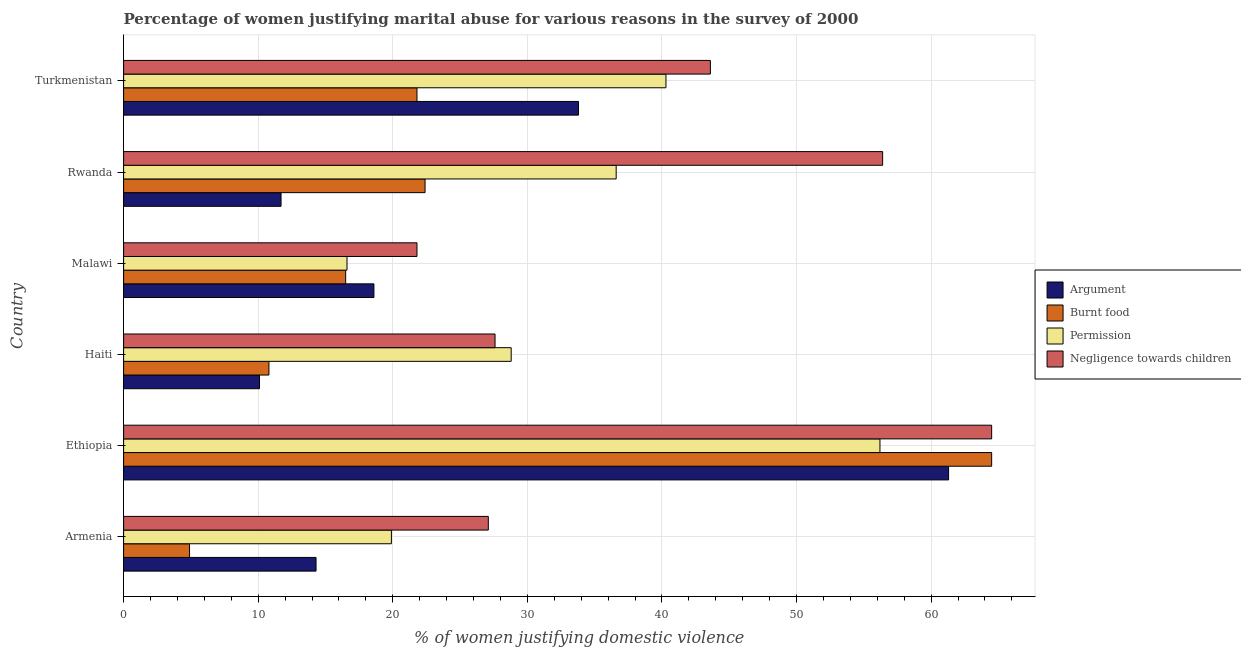How many groups of bars are there?
Ensure brevity in your answer.  6. Are the number of bars per tick equal to the number of legend labels?
Provide a short and direct response. Yes. Are the number of bars on each tick of the Y-axis equal?
Offer a very short reply. Yes. How many bars are there on the 1st tick from the top?
Your answer should be very brief. 4. What is the label of the 3rd group of bars from the top?
Your answer should be very brief. Malawi. What is the percentage of women justifying abuse for showing negligence towards children in Armenia?
Ensure brevity in your answer.  27.1. Across all countries, what is the maximum percentage of women justifying abuse in the case of an argument?
Your response must be concise. 61.3. Across all countries, what is the minimum percentage of women justifying abuse for burning food?
Offer a terse response. 4.9. In which country was the percentage of women justifying abuse for burning food maximum?
Offer a terse response. Ethiopia. In which country was the percentage of women justifying abuse for going without permission minimum?
Make the answer very short. Malawi. What is the total percentage of women justifying abuse for showing negligence towards children in the graph?
Offer a terse response. 241. What is the difference between the percentage of women justifying abuse for burning food in Armenia and the percentage of women justifying abuse for showing negligence towards children in Rwanda?
Provide a succinct answer. -51.5. What is the average percentage of women justifying abuse for burning food per country?
Ensure brevity in your answer.  23.48. What is the difference between the percentage of women justifying abuse for going without permission and percentage of women justifying abuse for showing negligence towards children in Haiti?
Offer a very short reply. 1.2. What is the ratio of the percentage of women justifying abuse for burning food in Armenia to that in Ethiopia?
Provide a short and direct response. 0.08. Is the percentage of women justifying abuse in the case of an argument in Armenia less than that in Malawi?
Offer a terse response. Yes. Is the difference between the percentage of women justifying abuse for showing negligence towards children in Malawi and Turkmenistan greater than the difference between the percentage of women justifying abuse for burning food in Malawi and Turkmenistan?
Give a very brief answer. No. What is the difference between the highest and the lowest percentage of women justifying abuse in the case of an argument?
Your response must be concise. 51.2. In how many countries, is the percentage of women justifying abuse in the case of an argument greater than the average percentage of women justifying abuse in the case of an argument taken over all countries?
Your response must be concise. 2. Is the sum of the percentage of women justifying abuse for burning food in Armenia and Ethiopia greater than the maximum percentage of women justifying abuse for showing negligence towards children across all countries?
Provide a short and direct response. Yes. What does the 2nd bar from the top in Haiti represents?
Your response must be concise. Permission. What does the 1st bar from the bottom in Malawi represents?
Ensure brevity in your answer.  Argument. Are the values on the major ticks of X-axis written in scientific E-notation?
Your response must be concise. No. Does the graph contain any zero values?
Provide a short and direct response. No. How many legend labels are there?
Ensure brevity in your answer.  4. What is the title of the graph?
Give a very brief answer. Percentage of women justifying marital abuse for various reasons in the survey of 2000. Does "Japan" appear as one of the legend labels in the graph?
Your response must be concise. No. What is the label or title of the X-axis?
Ensure brevity in your answer.  % of women justifying domestic violence. What is the label or title of the Y-axis?
Your answer should be compact. Country. What is the % of women justifying domestic violence in Burnt food in Armenia?
Keep it short and to the point. 4.9. What is the % of women justifying domestic violence in Negligence towards children in Armenia?
Offer a very short reply. 27.1. What is the % of women justifying domestic violence of Argument in Ethiopia?
Ensure brevity in your answer.  61.3. What is the % of women justifying domestic violence in Burnt food in Ethiopia?
Ensure brevity in your answer.  64.5. What is the % of women justifying domestic violence of Permission in Ethiopia?
Offer a terse response. 56.2. What is the % of women justifying domestic violence in Negligence towards children in Ethiopia?
Your answer should be very brief. 64.5. What is the % of women justifying domestic violence in Permission in Haiti?
Provide a succinct answer. 28.8. What is the % of women justifying domestic violence in Negligence towards children in Haiti?
Provide a succinct answer. 27.6. What is the % of women justifying domestic violence in Argument in Malawi?
Provide a short and direct response. 18.6. What is the % of women justifying domestic violence of Negligence towards children in Malawi?
Provide a succinct answer. 21.8. What is the % of women justifying domestic violence of Burnt food in Rwanda?
Make the answer very short. 22.4. What is the % of women justifying domestic violence in Permission in Rwanda?
Offer a very short reply. 36.6. What is the % of women justifying domestic violence in Negligence towards children in Rwanda?
Provide a short and direct response. 56.4. What is the % of women justifying domestic violence of Argument in Turkmenistan?
Ensure brevity in your answer.  33.8. What is the % of women justifying domestic violence of Burnt food in Turkmenistan?
Offer a terse response. 21.8. What is the % of women justifying domestic violence of Permission in Turkmenistan?
Make the answer very short. 40.3. What is the % of women justifying domestic violence in Negligence towards children in Turkmenistan?
Provide a succinct answer. 43.6. Across all countries, what is the maximum % of women justifying domestic violence of Argument?
Ensure brevity in your answer.  61.3. Across all countries, what is the maximum % of women justifying domestic violence of Burnt food?
Your answer should be compact. 64.5. Across all countries, what is the maximum % of women justifying domestic violence in Permission?
Offer a very short reply. 56.2. Across all countries, what is the maximum % of women justifying domestic violence in Negligence towards children?
Offer a terse response. 64.5. Across all countries, what is the minimum % of women justifying domestic violence of Argument?
Keep it short and to the point. 10.1. Across all countries, what is the minimum % of women justifying domestic violence of Burnt food?
Make the answer very short. 4.9. Across all countries, what is the minimum % of women justifying domestic violence in Permission?
Your answer should be very brief. 16.6. Across all countries, what is the minimum % of women justifying domestic violence of Negligence towards children?
Make the answer very short. 21.8. What is the total % of women justifying domestic violence of Argument in the graph?
Keep it short and to the point. 149.8. What is the total % of women justifying domestic violence of Burnt food in the graph?
Offer a terse response. 140.9. What is the total % of women justifying domestic violence of Permission in the graph?
Your answer should be very brief. 198.4. What is the total % of women justifying domestic violence of Negligence towards children in the graph?
Offer a terse response. 241. What is the difference between the % of women justifying domestic violence in Argument in Armenia and that in Ethiopia?
Your answer should be compact. -47. What is the difference between the % of women justifying domestic violence in Burnt food in Armenia and that in Ethiopia?
Your response must be concise. -59.6. What is the difference between the % of women justifying domestic violence in Permission in Armenia and that in Ethiopia?
Give a very brief answer. -36.3. What is the difference between the % of women justifying domestic violence of Negligence towards children in Armenia and that in Ethiopia?
Your response must be concise. -37.4. What is the difference between the % of women justifying domestic violence in Argument in Armenia and that in Haiti?
Keep it short and to the point. 4.2. What is the difference between the % of women justifying domestic violence of Negligence towards children in Armenia and that in Haiti?
Keep it short and to the point. -0.5. What is the difference between the % of women justifying domestic violence in Burnt food in Armenia and that in Malawi?
Your answer should be very brief. -11.6. What is the difference between the % of women justifying domestic violence in Permission in Armenia and that in Malawi?
Offer a very short reply. 3.3. What is the difference between the % of women justifying domestic violence of Negligence towards children in Armenia and that in Malawi?
Provide a succinct answer. 5.3. What is the difference between the % of women justifying domestic violence in Burnt food in Armenia and that in Rwanda?
Offer a very short reply. -17.5. What is the difference between the % of women justifying domestic violence in Permission in Armenia and that in Rwanda?
Give a very brief answer. -16.7. What is the difference between the % of women justifying domestic violence of Negligence towards children in Armenia and that in Rwanda?
Provide a succinct answer. -29.3. What is the difference between the % of women justifying domestic violence in Argument in Armenia and that in Turkmenistan?
Offer a very short reply. -19.5. What is the difference between the % of women justifying domestic violence in Burnt food in Armenia and that in Turkmenistan?
Provide a succinct answer. -16.9. What is the difference between the % of women justifying domestic violence in Permission in Armenia and that in Turkmenistan?
Keep it short and to the point. -20.4. What is the difference between the % of women justifying domestic violence in Negligence towards children in Armenia and that in Turkmenistan?
Offer a very short reply. -16.5. What is the difference between the % of women justifying domestic violence of Argument in Ethiopia and that in Haiti?
Provide a short and direct response. 51.2. What is the difference between the % of women justifying domestic violence in Burnt food in Ethiopia and that in Haiti?
Provide a succinct answer. 53.7. What is the difference between the % of women justifying domestic violence of Permission in Ethiopia and that in Haiti?
Your answer should be compact. 27.4. What is the difference between the % of women justifying domestic violence in Negligence towards children in Ethiopia and that in Haiti?
Provide a succinct answer. 36.9. What is the difference between the % of women justifying domestic violence in Argument in Ethiopia and that in Malawi?
Your answer should be compact. 42.7. What is the difference between the % of women justifying domestic violence of Permission in Ethiopia and that in Malawi?
Provide a short and direct response. 39.6. What is the difference between the % of women justifying domestic violence of Negligence towards children in Ethiopia and that in Malawi?
Ensure brevity in your answer.  42.7. What is the difference between the % of women justifying domestic violence in Argument in Ethiopia and that in Rwanda?
Keep it short and to the point. 49.6. What is the difference between the % of women justifying domestic violence of Burnt food in Ethiopia and that in Rwanda?
Provide a succinct answer. 42.1. What is the difference between the % of women justifying domestic violence in Permission in Ethiopia and that in Rwanda?
Ensure brevity in your answer.  19.6. What is the difference between the % of women justifying domestic violence in Negligence towards children in Ethiopia and that in Rwanda?
Offer a very short reply. 8.1. What is the difference between the % of women justifying domestic violence in Argument in Ethiopia and that in Turkmenistan?
Provide a succinct answer. 27.5. What is the difference between the % of women justifying domestic violence in Burnt food in Ethiopia and that in Turkmenistan?
Offer a terse response. 42.7. What is the difference between the % of women justifying domestic violence in Negligence towards children in Ethiopia and that in Turkmenistan?
Keep it short and to the point. 20.9. What is the difference between the % of women justifying domestic violence in Burnt food in Haiti and that in Rwanda?
Offer a terse response. -11.6. What is the difference between the % of women justifying domestic violence of Negligence towards children in Haiti and that in Rwanda?
Provide a succinct answer. -28.8. What is the difference between the % of women justifying domestic violence of Argument in Haiti and that in Turkmenistan?
Your answer should be compact. -23.7. What is the difference between the % of women justifying domestic violence of Burnt food in Haiti and that in Turkmenistan?
Give a very brief answer. -11. What is the difference between the % of women justifying domestic violence of Negligence towards children in Haiti and that in Turkmenistan?
Make the answer very short. -16. What is the difference between the % of women justifying domestic violence of Argument in Malawi and that in Rwanda?
Your answer should be very brief. 6.9. What is the difference between the % of women justifying domestic violence in Permission in Malawi and that in Rwanda?
Give a very brief answer. -20. What is the difference between the % of women justifying domestic violence of Negligence towards children in Malawi and that in Rwanda?
Offer a terse response. -34.6. What is the difference between the % of women justifying domestic violence in Argument in Malawi and that in Turkmenistan?
Offer a very short reply. -15.2. What is the difference between the % of women justifying domestic violence in Permission in Malawi and that in Turkmenistan?
Your response must be concise. -23.7. What is the difference between the % of women justifying domestic violence of Negligence towards children in Malawi and that in Turkmenistan?
Make the answer very short. -21.8. What is the difference between the % of women justifying domestic violence of Argument in Rwanda and that in Turkmenistan?
Give a very brief answer. -22.1. What is the difference between the % of women justifying domestic violence in Permission in Rwanda and that in Turkmenistan?
Provide a short and direct response. -3.7. What is the difference between the % of women justifying domestic violence of Argument in Armenia and the % of women justifying domestic violence of Burnt food in Ethiopia?
Your response must be concise. -50.2. What is the difference between the % of women justifying domestic violence of Argument in Armenia and the % of women justifying domestic violence of Permission in Ethiopia?
Keep it short and to the point. -41.9. What is the difference between the % of women justifying domestic violence in Argument in Armenia and the % of women justifying domestic violence in Negligence towards children in Ethiopia?
Offer a very short reply. -50.2. What is the difference between the % of women justifying domestic violence in Burnt food in Armenia and the % of women justifying domestic violence in Permission in Ethiopia?
Provide a short and direct response. -51.3. What is the difference between the % of women justifying domestic violence of Burnt food in Armenia and the % of women justifying domestic violence of Negligence towards children in Ethiopia?
Offer a very short reply. -59.6. What is the difference between the % of women justifying domestic violence of Permission in Armenia and the % of women justifying domestic violence of Negligence towards children in Ethiopia?
Make the answer very short. -44.6. What is the difference between the % of women justifying domestic violence in Argument in Armenia and the % of women justifying domestic violence in Permission in Haiti?
Provide a succinct answer. -14.5. What is the difference between the % of women justifying domestic violence in Argument in Armenia and the % of women justifying domestic violence in Negligence towards children in Haiti?
Give a very brief answer. -13.3. What is the difference between the % of women justifying domestic violence in Burnt food in Armenia and the % of women justifying domestic violence in Permission in Haiti?
Give a very brief answer. -23.9. What is the difference between the % of women justifying domestic violence in Burnt food in Armenia and the % of women justifying domestic violence in Negligence towards children in Haiti?
Your answer should be very brief. -22.7. What is the difference between the % of women justifying domestic violence in Burnt food in Armenia and the % of women justifying domestic violence in Negligence towards children in Malawi?
Keep it short and to the point. -16.9. What is the difference between the % of women justifying domestic violence in Argument in Armenia and the % of women justifying domestic violence in Permission in Rwanda?
Your response must be concise. -22.3. What is the difference between the % of women justifying domestic violence in Argument in Armenia and the % of women justifying domestic violence in Negligence towards children in Rwanda?
Provide a succinct answer. -42.1. What is the difference between the % of women justifying domestic violence in Burnt food in Armenia and the % of women justifying domestic violence in Permission in Rwanda?
Keep it short and to the point. -31.7. What is the difference between the % of women justifying domestic violence in Burnt food in Armenia and the % of women justifying domestic violence in Negligence towards children in Rwanda?
Keep it short and to the point. -51.5. What is the difference between the % of women justifying domestic violence of Permission in Armenia and the % of women justifying domestic violence of Negligence towards children in Rwanda?
Your response must be concise. -36.5. What is the difference between the % of women justifying domestic violence in Argument in Armenia and the % of women justifying domestic violence in Permission in Turkmenistan?
Offer a very short reply. -26. What is the difference between the % of women justifying domestic violence of Argument in Armenia and the % of women justifying domestic violence of Negligence towards children in Turkmenistan?
Offer a terse response. -29.3. What is the difference between the % of women justifying domestic violence of Burnt food in Armenia and the % of women justifying domestic violence of Permission in Turkmenistan?
Your response must be concise. -35.4. What is the difference between the % of women justifying domestic violence in Burnt food in Armenia and the % of women justifying domestic violence in Negligence towards children in Turkmenistan?
Make the answer very short. -38.7. What is the difference between the % of women justifying domestic violence in Permission in Armenia and the % of women justifying domestic violence in Negligence towards children in Turkmenistan?
Make the answer very short. -23.7. What is the difference between the % of women justifying domestic violence in Argument in Ethiopia and the % of women justifying domestic violence in Burnt food in Haiti?
Give a very brief answer. 50.5. What is the difference between the % of women justifying domestic violence of Argument in Ethiopia and the % of women justifying domestic violence of Permission in Haiti?
Provide a succinct answer. 32.5. What is the difference between the % of women justifying domestic violence in Argument in Ethiopia and the % of women justifying domestic violence in Negligence towards children in Haiti?
Make the answer very short. 33.7. What is the difference between the % of women justifying domestic violence of Burnt food in Ethiopia and the % of women justifying domestic violence of Permission in Haiti?
Ensure brevity in your answer.  35.7. What is the difference between the % of women justifying domestic violence in Burnt food in Ethiopia and the % of women justifying domestic violence in Negligence towards children in Haiti?
Give a very brief answer. 36.9. What is the difference between the % of women justifying domestic violence in Permission in Ethiopia and the % of women justifying domestic violence in Negligence towards children in Haiti?
Make the answer very short. 28.6. What is the difference between the % of women justifying domestic violence of Argument in Ethiopia and the % of women justifying domestic violence of Burnt food in Malawi?
Your answer should be compact. 44.8. What is the difference between the % of women justifying domestic violence of Argument in Ethiopia and the % of women justifying domestic violence of Permission in Malawi?
Your answer should be compact. 44.7. What is the difference between the % of women justifying domestic violence in Argument in Ethiopia and the % of women justifying domestic violence in Negligence towards children in Malawi?
Your answer should be very brief. 39.5. What is the difference between the % of women justifying domestic violence in Burnt food in Ethiopia and the % of women justifying domestic violence in Permission in Malawi?
Give a very brief answer. 47.9. What is the difference between the % of women justifying domestic violence in Burnt food in Ethiopia and the % of women justifying domestic violence in Negligence towards children in Malawi?
Give a very brief answer. 42.7. What is the difference between the % of women justifying domestic violence in Permission in Ethiopia and the % of women justifying domestic violence in Negligence towards children in Malawi?
Keep it short and to the point. 34.4. What is the difference between the % of women justifying domestic violence of Argument in Ethiopia and the % of women justifying domestic violence of Burnt food in Rwanda?
Provide a succinct answer. 38.9. What is the difference between the % of women justifying domestic violence of Argument in Ethiopia and the % of women justifying domestic violence of Permission in Rwanda?
Your answer should be compact. 24.7. What is the difference between the % of women justifying domestic violence in Argument in Ethiopia and the % of women justifying domestic violence in Negligence towards children in Rwanda?
Offer a very short reply. 4.9. What is the difference between the % of women justifying domestic violence of Burnt food in Ethiopia and the % of women justifying domestic violence of Permission in Rwanda?
Provide a succinct answer. 27.9. What is the difference between the % of women justifying domestic violence in Burnt food in Ethiopia and the % of women justifying domestic violence in Negligence towards children in Rwanda?
Provide a short and direct response. 8.1. What is the difference between the % of women justifying domestic violence of Argument in Ethiopia and the % of women justifying domestic violence of Burnt food in Turkmenistan?
Your answer should be very brief. 39.5. What is the difference between the % of women justifying domestic violence of Burnt food in Ethiopia and the % of women justifying domestic violence of Permission in Turkmenistan?
Keep it short and to the point. 24.2. What is the difference between the % of women justifying domestic violence of Burnt food in Ethiopia and the % of women justifying domestic violence of Negligence towards children in Turkmenistan?
Ensure brevity in your answer.  20.9. What is the difference between the % of women justifying domestic violence of Argument in Haiti and the % of women justifying domestic violence of Permission in Malawi?
Provide a succinct answer. -6.5. What is the difference between the % of women justifying domestic violence in Argument in Haiti and the % of women justifying domestic violence in Permission in Rwanda?
Keep it short and to the point. -26.5. What is the difference between the % of women justifying domestic violence in Argument in Haiti and the % of women justifying domestic violence in Negligence towards children in Rwanda?
Provide a succinct answer. -46.3. What is the difference between the % of women justifying domestic violence in Burnt food in Haiti and the % of women justifying domestic violence in Permission in Rwanda?
Your answer should be compact. -25.8. What is the difference between the % of women justifying domestic violence in Burnt food in Haiti and the % of women justifying domestic violence in Negligence towards children in Rwanda?
Provide a short and direct response. -45.6. What is the difference between the % of women justifying domestic violence of Permission in Haiti and the % of women justifying domestic violence of Negligence towards children in Rwanda?
Your answer should be very brief. -27.6. What is the difference between the % of women justifying domestic violence of Argument in Haiti and the % of women justifying domestic violence of Burnt food in Turkmenistan?
Your answer should be very brief. -11.7. What is the difference between the % of women justifying domestic violence of Argument in Haiti and the % of women justifying domestic violence of Permission in Turkmenistan?
Provide a short and direct response. -30.2. What is the difference between the % of women justifying domestic violence of Argument in Haiti and the % of women justifying domestic violence of Negligence towards children in Turkmenistan?
Offer a very short reply. -33.5. What is the difference between the % of women justifying domestic violence in Burnt food in Haiti and the % of women justifying domestic violence in Permission in Turkmenistan?
Offer a very short reply. -29.5. What is the difference between the % of women justifying domestic violence in Burnt food in Haiti and the % of women justifying domestic violence in Negligence towards children in Turkmenistan?
Offer a very short reply. -32.8. What is the difference between the % of women justifying domestic violence in Permission in Haiti and the % of women justifying domestic violence in Negligence towards children in Turkmenistan?
Provide a succinct answer. -14.8. What is the difference between the % of women justifying domestic violence in Argument in Malawi and the % of women justifying domestic violence in Burnt food in Rwanda?
Provide a short and direct response. -3.8. What is the difference between the % of women justifying domestic violence in Argument in Malawi and the % of women justifying domestic violence in Negligence towards children in Rwanda?
Keep it short and to the point. -37.8. What is the difference between the % of women justifying domestic violence of Burnt food in Malawi and the % of women justifying domestic violence of Permission in Rwanda?
Offer a terse response. -20.1. What is the difference between the % of women justifying domestic violence of Burnt food in Malawi and the % of women justifying domestic violence of Negligence towards children in Rwanda?
Offer a terse response. -39.9. What is the difference between the % of women justifying domestic violence in Permission in Malawi and the % of women justifying domestic violence in Negligence towards children in Rwanda?
Your response must be concise. -39.8. What is the difference between the % of women justifying domestic violence in Argument in Malawi and the % of women justifying domestic violence in Permission in Turkmenistan?
Ensure brevity in your answer.  -21.7. What is the difference between the % of women justifying domestic violence of Burnt food in Malawi and the % of women justifying domestic violence of Permission in Turkmenistan?
Make the answer very short. -23.8. What is the difference between the % of women justifying domestic violence in Burnt food in Malawi and the % of women justifying domestic violence in Negligence towards children in Turkmenistan?
Give a very brief answer. -27.1. What is the difference between the % of women justifying domestic violence of Permission in Malawi and the % of women justifying domestic violence of Negligence towards children in Turkmenistan?
Offer a terse response. -27. What is the difference between the % of women justifying domestic violence in Argument in Rwanda and the % of women justifying domestic violence in Burnt food in Turkmenistan?
Provide a succinct answer. -10.1. What is the difference between the % of women justifying domestic violence of Argument in Rwanda and the % of women justifying domestic violence of Permission in Turkmenistan?
Keep it short and to the point. -28.6. What is the difference between the % of women justifying domestic violence in Argument in Rwanda and the % of women justifying domestic violence in Negligence towards children in Turkmenistan?
Your answer should be compact. -31.9. What is the difference between the % of women justifying domestic violence in Burnt food in Rwanda and the % of women justifying domestic violence in Permission in Turkmenistan?
Give a very brief answer. -17.9. What is the difference between the % of women justifying domestic violence of Burnt food in Rwanda and the % of women justifying domestic violence of Negligence towards children in Turkmenistan?
Offer a very short reply. -21.2. What is the average % of women justifying domestic violence in Argument per country?
Your answer should be compact. 24.97. What is the average % of women justifying domestic violence in Burnt food per country?
Offer a very short reply. 23.48. What is the average % of women justifying domestic violence of Permission per country?
Your answer should be compact. 33.07. What is the average % of women justifying domestic violence in Negligence towards children per country?
Offer a very short reply. 40.17. What is the difference between the % of women justifying domestic violence of Argument and % of women justifying domestic violence of Burnt food in Armenia?
Give a very brief answer. 9.4. What is the difference between the % of women justifying domestic violence of Argument and % of women justifying domestic violence of Negligence towards children in Armenia?
Give a very brief answer. -12.8. What is the difference between the % of women justifying domestic violence of Burnt food and % of women justifying domestic violence of Negligence towards children in Armenia?
Make the answer very short. -22.2. What is the difference between the % of women justifying domestic violence in Argument and % of women justifying domestic violence in Burnt food in Ethiopia?
Your answer should be very brief. -3.2. What is the difference between the % of women justifying domestic violence of Burnt food and % of women justifying domestic violence of Negligence towards children in Ethiopia?
Offer a terse response. 0. What is the difference between the % of women justifying domestic violence of Permission and % of women justifying domestic violence of Negligence towards children in Ethiopia?
Offer a terse response. -8.3. What is the difference between the % of women justifying domestic violence in Argument and % of women justifying domestic violence in Burnt food in Haiti?
Offer a terse response. -0.7. What is the difference between the % of women justifying domestic violence of Argument and % of women justifying domestic violence of Permission in Haiti?
Your response must be concise. -18.7. What is the difference between the % of women justifying domestic violence of Argument and % of women justifying domestic violence of Negligence towards children in Haiti?
Your answer should be very brief. -17.5. What is the difference between the % of women justifying domestic violence of Burnt food and % of women justifying domestic violence of Negligence towards children in Haiti?
Offer a terse response. -16.8. What is the difference between the % of women justifying domestic violence of Permission and % of women justifying domestic violence of Negligence towards children in Haiti?
Offer a terse response. 1.2. What is the difference between the % of women justifying domestic violence in Burnt food and % of women justifying domestic violence in Permission in Malawi?
Provide a succinct answer. -0.1. What is the difference between the % of women justifying domestic violence of Burnt food and % of women justifying domestic violence of Negligence towards children in Malawi?
Your response must be concise. -5.3. What is the difference between the % of women justifying domestic violence of Argument and % of women justifying domestic violence of Burnt food in Rwanda?
Your response must be concise. -10.7. What is the difference between the % of women justifying domestic violence of Argument and % of women justifying domestic violence of Permission in Rwanda?
Make the answer very short. -24.9. What is the difference between the % of women justifying domestic violence in Argument and % of women justifying domestic violence in Negligence towards children in Rwanda?
Give a very brief answer. -44.7. What is the difference between the % of women justifying domestic violence of Burnt food and % of women justifying domestic violence of Permission in Rwanda?
Provide a short and direct response. -14.2. What is the difference between the % of women justifying domestic violence of Burnt food and % of women justifying domestic violence of Negligence towards children in Rwanda?
Your answer should be compact. -34. What is the difference between the % of women justifying domestic violence of Permission and % of women justifying domestic violence of Negligence towards children in Rwanda?
Provide a short and direct response. -19.8. What is the difference between the % of women justifying domestic violence in Argument and % of women justifying domestic violence in Permission in Turkmenistan?
Offer a very short reply. -6.5. What is the difference between the % of women justifying domestic violence in Argument and % of women justifying domestic violence in Negligence towards children in Turkmenistan?
Your answer should be compact. -9.8. What is the difference between the % of women justifying domestic violence of Burnt food and % of women justifying domestic violence of Permission in Turkmenistan?
Your answer should be very brief. -18.5. What is the difference between the % of women justifying domestic violence of Burnt food and % of women justifying domestic violence of Negligence towards children in Turkmenistan?
Offer a very short reply. -21.8. What is the difference between the % of women justifying domestic violence in Permission and % of women justifying domestic violence in Negligence towards children in Turkmenistan?
Offer a very short reply. -3.3. What is the ratio of the % of women justifying domestic violence of Argument in Armenia to that in Ethiopia?
Keep it short and to the point. 0.23. What is the ratio of the % of women justifying domestic violence in Burnt food in Armenia to that in Ethiopia?
Provide a short and direct response. 0.08. What is the ratio of the % of women justifying domestic violence of Permission in Armenia to that in Ethiopia?
Offer a very short reply. 0.35. What is the ratio of the % of women justifying domestic violence in Negligence towards children in Armenia to that in Ethiopia?
Provide a short and direct response. 0.42. What is the ratio of the % of women justifying domestic violence of Argument in Armenia to that in Haiti?
Your answer should be compact. 1.42. What is the ratio of the % of women justifying domestic violence of Burnt food in Armenia to that in Haiti?
Your answer should be compact. 0.45. What is the ratio of the % of women justifying domestic violence in Permission in Armenia to that in Haiti?
Ensure brevity in your answer.  0.69. What is the ratio of the % of women justifying domestic violence in Negligence towards children in Armenia to that in Haiti?
Your answer should be compact. 0.98. What is the ratio of the % of women justifying domestic violence in Argument in Armenia to that in Malawi?
Keep it short and to the point. 0.77. What is the ratio of the % of women justifying domestic violence in Burnt food in Armenia to that in Malawi?
Your answer should be very brief. 0.3. What is the ratio of the % of women justifying domestic violence in Permission in Armenia to that in Malawi?
Offer a terse response. 1.2. What is the ratio of the % of women justifying domestic violence in Negligence towards children in Armenia to that in Malawi?
Make the answer very short. 1.24. What is the ratio of the % of women justifying domestic violence of Argument in Armenia to that in Rwanda?
Your answer should be very brief. 1.22. What is the ratio of the % of women justifying domestic violence in Burnt food in Armenia to that in Rwanda?
Ensure brevity in your answer.  0.22. What is the ratio of the % of women justifying domestic violence in Permission in Armenia to that in Rwanda?
Your answer should be very brief. 0.54. What is the ratio of the % of women justifying domestic violence of Negligence towards children in Armenia to that in Rwanda?
Offer a terse response. 0.48. What is the ratio of the % of women justifying domestic violence of Argument in Armenia to that in Turkmenistan?
Ensure brevity in your answer.  0.42. What is the ratio of the % of women justifying domestic violence in Burnt food in Armenia to that in Turkmenistan?
Provide a short and direct response. 0.22. What is the ratio of the % of women justifying domestic violence of Permission in Armenia to that in Turkmenistan?
Your answer should be very brief. 0.49. What is the ratio of the % of women justifying domestic violence of Negligence towards children in Armenia to that in Turkmenistan?
Offer a terse response. 0.62. What is the ratio of the % of women justifying domestic violence in Argument in Ethiopia to that in Haiti?
Offer a terse response. 6.07. What is the ratio of the % of women justifying domestic violence of Burnt food in Ethiopia to that in Haiti?
Offer a terse response. 5.97. What is the ratio of the % of women justifying domestic violence of Permission in Ethiopia to that in Haiti?
Offer a terse response. 1.95. What is the ratio of the % of women justifying domestic violence in Negligence towards children in Ethiopia to that in Haiti?
Keep it short and to the point. 2.34. What is the ratio of the % of women justifying domestic violence in Argument in Ethiopia to that in Malawi?
Make the answer very short. 3.3. What is the ratio of the % of women justifying domestic violence in Burnt food in Ethiopia to that in Malawi?
Offer a terse response. 3.91. What is the ratio of the % of women justifying domestic violence of Permission in Ethiopia to that in Malawi?
Your answer should be compact. 3.39. What is the ratio of the % of women justifying domestic violence in Negligence towards children in Ethiopia to that in Malawi?
Your answer should be very brief. 2.96. What is the ratio of the % of women justifying domestic violence in Argument in Ethiopia to that in Rwanda?
Offer a very short reply. 5.24. What is the ratio of the % of women justifying domestic violence in Burnt food in Ethiopia to that in Rwanda?
Ensure brevity in your answer.  2.88. What is the ratio of the % of women justifying domestic violence in Permission in Ethiopia to that in Rwanda?
Keep it short and to the point. 1.54. What is the ratio of the % of women justifying domestic violence in Negligence towards children in Ethiopia to that in Rwanda?
Provide a succinct answer. 1.14. What is the ratio of the % of women justifying domestic violence in Argument in Ethiopia to that in Turkmenistan?
Make the answer very short. 1.81. What is the ratio of the % of women justifying domestic violence of Burnt food in Ethiopia to that in Turkmenistan?
Your response must be concise. 2.96. What is the ratio of the % of women justifying domestic violence in Permission in Ethiopia to that in Turkmenistan?
Your answer should be very brief. 1.39. What is the ratio of the % of women justifying domestic violence of Negligence towards children in Ethiopia to that in Turkmenistan?
Your answer should be compact. 1.48. What is the ratio of the % of women justifying domestic violence in Argument in Haiti to that in Malawi?
Give a very brief answer. 0.54. What is the ratio of the % of women justifying domestic violence of Burnt food in Haiti to that in Malawi?
Offer a terse response. 0.65. What is the ratio of the % of women justifying domestic violence in Permission in Haiti to that in Malawi?
Ensure brevity in your answer.  1.73. What is the ratio of the % of women justifying domestic violence in Negligence towards children in Haiti to that in Malawi?
Give a very brief answer. 1.27. What is the ratio of the % of women justifying domestic violence of Argument in Haiti to that in Rwanda?
Your response must be concise. 0.86. What is the ratio of the % of women justifying domestic violence in Burnt food in Haiti to that in Rwanda?
Offer a terse response. 0.48. What is the ratio of the % of women justifying domestic violence of Permission in Haiti to that in Rwanda?
Make the answer very short. 0.79. What is the ratio of the % of women justifying domestic violence of Negligence towards children in Haiti to that in Rwanda?
Offer a terse response. 0.49. What is the ratio of the % of women justifying domestic violence in Argument in Haiti to that in Turkmenistan?
Your answer should be very brief. 0.3. What is the ratio of the % of women justifying domestic violence of Burnt food in Haiti to that in Turkmenistan?
Your answer should be compact. 0.5. What is the ratio of the % of women justifying domestic violence in Permission in Haiti to that in Turkmenistan?
Provide a succinct answer. 0.71. What is the ratio of the % of women justifying domestic violence in Negligence towards children in Haiti to that in Turkmenistan?
Your response must be concise. 0.63. What is the ratio of the % of women justifying domestic violence of Argument in Malawi to that in Rwanda?
Keep it short and to the point. 1.59. What is the ratio of the % of women justifying domestic violence in Burnt food in Malawi to that in Rwanda?
Keep it short and to the point. 0.74. What is the ratio of the % of women justifying domestic violence of Permission in Malawi to that in Rwanda?
Your answer should be very brief. 0.45. What is the ratio of the % of women justifying domestic violence of Negligence towards children in Malawi to that in Rwanda?
Provide a succinct answer. 0.39. What is the ratio of the % of women justifying domestic violence in Argument in Malawi to that in Turkmenistan?
Provide a succinct answer. 0.55. What is the ratio of the % of women justifying domestic violence in Burnt food in Malawi to that in Turkmenistan?
Your answer should be compact. 0.76. What is the ratio of the % of women justifying domestic violence of Permission in Malawi to that in Turkmenistan?
Your response must be concise. 0.41. What is the ratio of the % of women justifying domestic violence in Argument in Rwanda to that in Turkmenistan?
Your response must be concise. 0.35. What is the ratio of the % of women justifying domestic violence of Burnt food in Rwanda to that in Turkmenistan?
Keep it short and to the point. 1.03. What is the ratio of the % of women justifying domestic violence of Permission in Rwanda to that in Turkmenistan?
Give a very brief answer. 0.91. What is the ratio of the % of women justifying domestic violence of Negligence towards children in Rwanda to that in Turkmenistan?
Provide a succinct answer. 1.29. What is the difference between the highest and the second highest % of women justifying domestic violence of Argument?
Offer a terse response. 27.5. What is the difference between the highest and the second highest % of women justifying domestic violence of Burnt food?
Offer a very short reply. 42.1. What is the difference between the highest and the second highest % of women justifying domestic violence of Permission?
Your response must be concise. 15.9. What is the difference between the highest and the lowest % of women justifying domestic violence in Argument?
Provide a succinct answer. 51.2. What is the difference between the highest and the lowest % of women justifying domestic violence of Burnt food?
Offer a terse response. 59.6. What is the difference between the highest and the lowest % of women justifying domestic violence of Permission?
Give a very brief answer. 39.6. What is the difference between the highest and the lowest % of women justifying domestic violence in Negligence towards children?
Give a very brief answer. 42.7. 